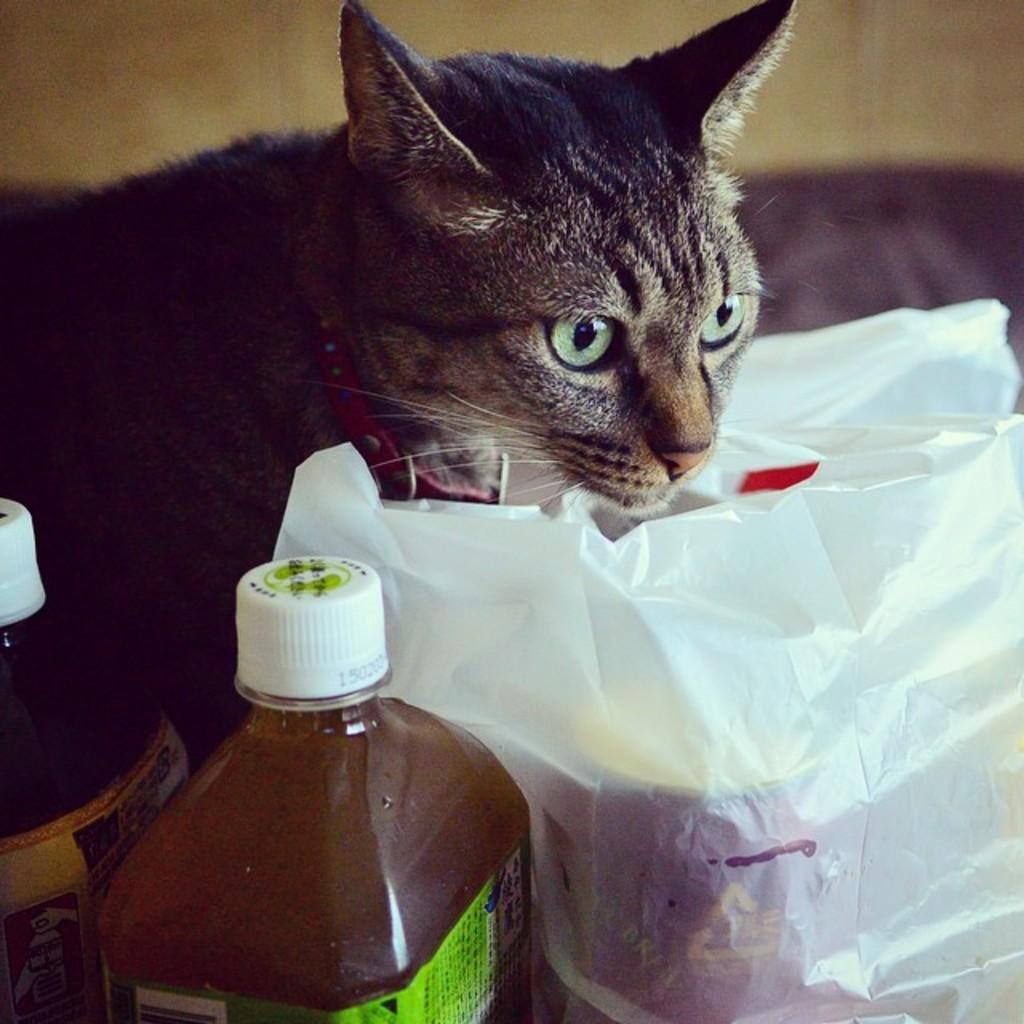What type of animal is in the image? There is a cat in the image. What object can be seen next to the cat? There is a bottle in the image. What other item is present in the image? There is a plastic bag in the image. What type of light source is illuminating the cat in the image? There is no specific light source mentioned or visible in the image, so it cannot be determined. 